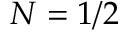<formula> <loc_0><loc_0><loc_500><loc_500>N = 1 / 2</formula> 